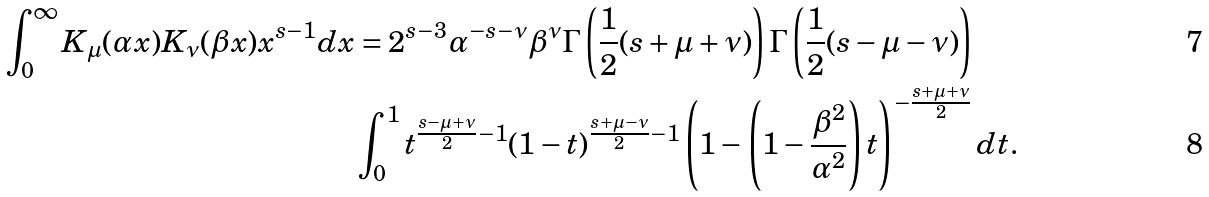Convert formula to latex. <formula><loc_0><loc_0><loc_500><loc_500>\int _ { 0 } ^ { \infty } K _ { \mu } ( \alpha x ) K _ { \nu } ( \beta x ) x ^ { s - 1 } d x & = 2 ^ { s - 3 } \alpha ^ { - s - \nu } \beta ^ { \nu } \Gamma \left ( \frac { 1 } { 2 } ( s + \mu + \nu ) \right ) \Gamma \left ( \frac { 1 } { 2 } ( s - \mu - \nu ) \right ) \\ & \int _ { 0 } ^ { 1 } t ^ { \frac { s - \mu + \nu } { 2 } - 1 } ( 1 - t ) ^ { \frac { s + \mu - \nu } { 2 } - 1 } \left ( 1 - \left ( 1 - \frac { \beta ^ { 2 } } { \alpha ^ { 2 } } \right ) t \right ) ^ { - \frac { s + \mu + \nu } { 2 } } d t .</formula> 